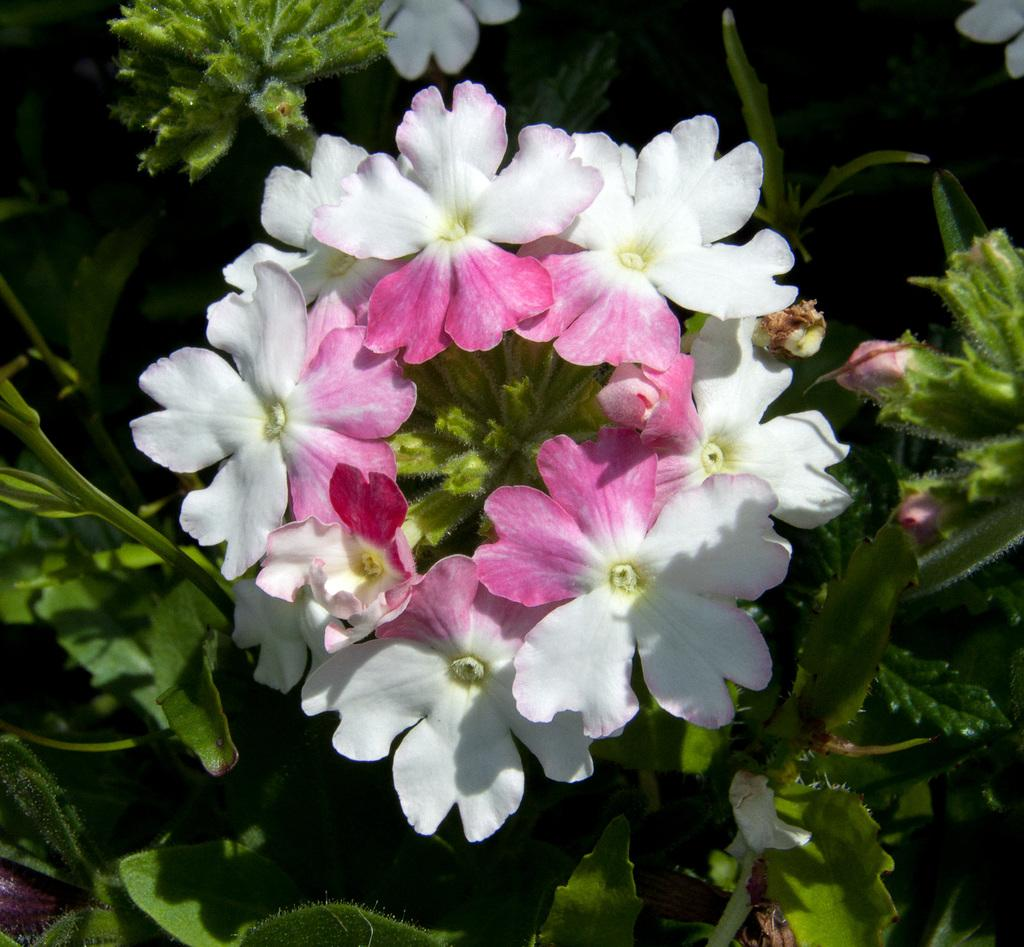What is the main subject of the image? The main subject of the image is flowers. Where are the flowers located in the image? The flowers are in the center of the image. What else can be seen in the background of the image? There are leaves in the background of the image. What design is featured on the net in the image? There is no net present in the image; it only contains flowers and leaves. 